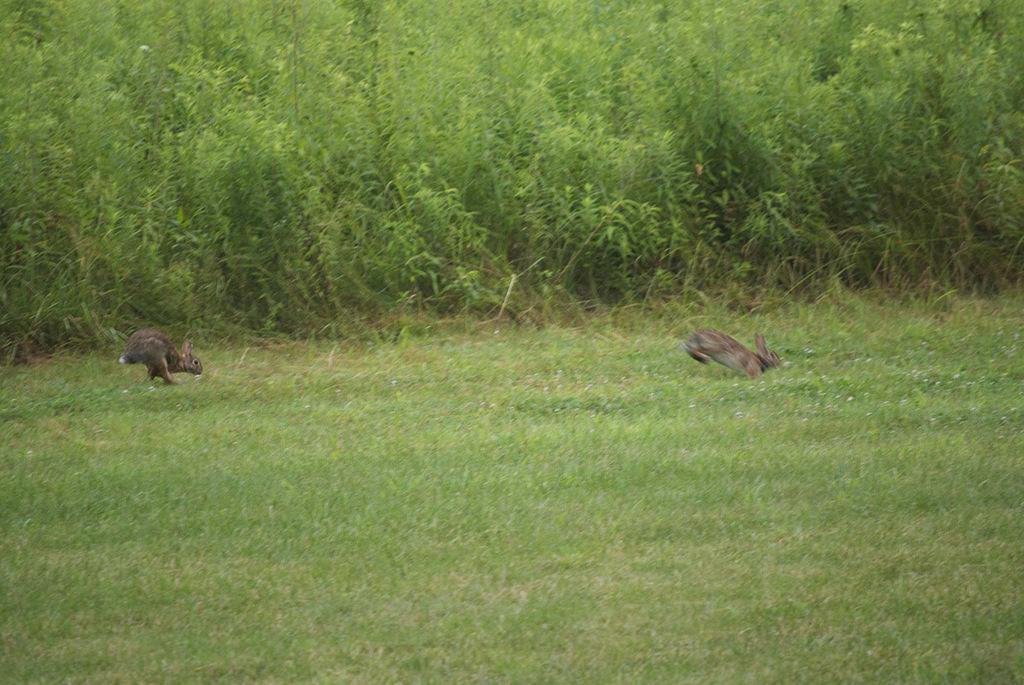Describe this image in one or two sentences. In this image there are two rabbits which are running in the ground. In the background there are plants. On the ground there is grass. 